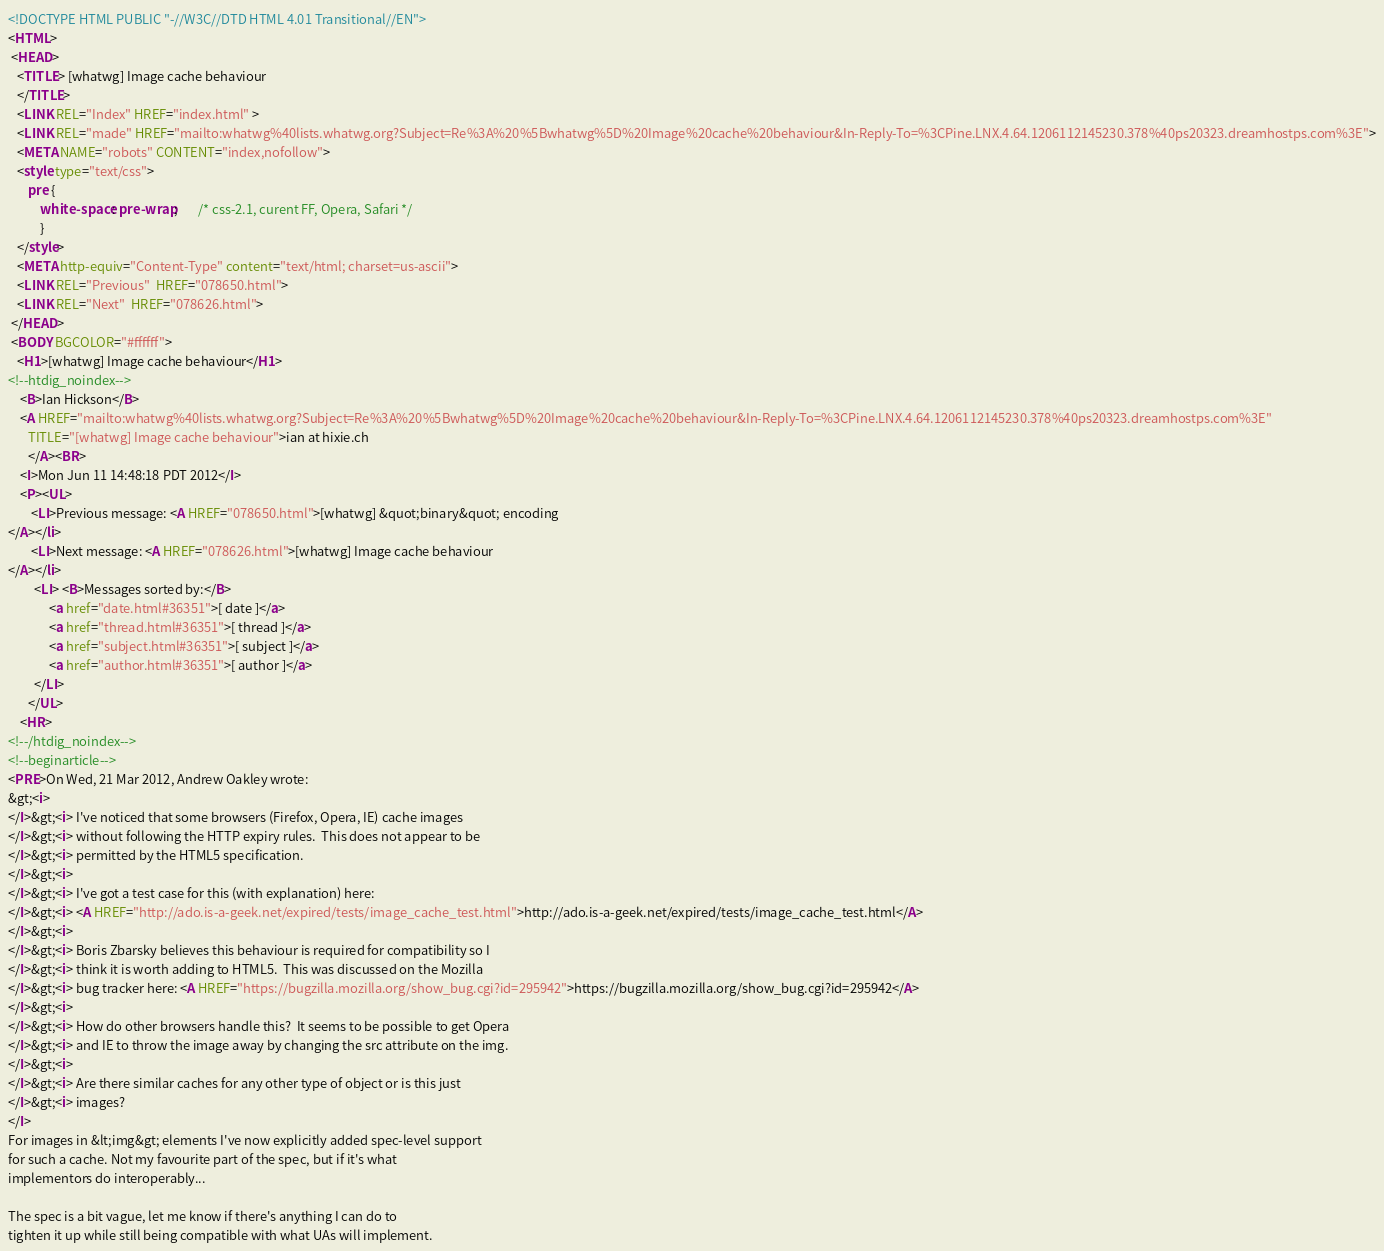Convert code to text. <code><loc_0><loc_0><loc_500><loc_500><_HTML_><!DOCTYPE HTML PUBLIC "-//W3C//DTD HTML 4.01 Transitional//EN">
<HTML>
 <HEAD>
   <TITLE> [whatwg] Image cache behaviour
   </TITLE>
   <LINK REL="Index" HREF="index.html" >
   <LINK REL="made" HREF="mailto:whatwg%40lists.whatwg.org?Subject=Re%3A%20%5Bwhatwg%5D%20Image%20cache%20behaviour&In-Reply-To=%3CPine.LNX.4.64.1206112145230.378%40ps20323.dreamhostps.com%3E">
   <META NAME="robots" CONTENT="index,nofollow">
   <style type="text/css">
       pre {
           white-space: pre-wrap;       /* css-2.1, curent FF, Opera, Safari */
           }
   </style>
   <META http-equiv="Content-Type" content="text/html; charset=us-ascii">
   <LINK REL="Previous"  HREF="078650.html">
   <LINK REL="Next"  HREF="078626.html">
 </HEAD>
 <BODY BGCOLOR="#ffffff">
   <H1>[whatwg] Image cache behaviour</H1>
<!--htdig_noindex-->
    <B>Ian Hickson</B> 
    <A HREF="mailto:whatwg%40lists.whatwg.org?Subject=Re%3A%20%5Bwhatwg%5D%20Image%20cache%20behaviour&In-Reply-To=%3CPine.LNX.4.64.1206112145230.378%40ps20323.dreamhostps.com%3E"
       TITLE="[whatwg] Image cache behaviour">ian at hixie.ch
       </A><BR>
    <I>Mon Jun 11 14:48:18 PDT 2012</I>
    <P><UL>
        <LI>Previous message: <A HREF="078650.html">[whatwg] &quot;binary&quot; encoding
</A></li>
        <LI>Next message: <A HREF="078626.html">[whatwg] Image cache behaviour
</A></li>
         <LI> <B>Messages sorted by:</B> 
              <a href="date.html#36351">[ date ]</a>
              <a href="thread.html#36351">[ thread ]</a>
              <a href="subject.html#36351">[ subject ]</a>
              <a href="author.html#36351">[ author ]</a>
         </LI>
       </UL>
    <HR>  
<!--/htdig_noindex-->
<!--beginarticle-->
<PRE>On Wed, 21 Mar 2012, Andrew Oakley wrote:
&gt;<i>
</I>&gt;<i> I've noticed that some browsers (Firefox, Opera, IE) cache images 
</I>&gt;<i> without following the HTTP expiry rules.  This does not appear to be 
</I>&gt;<i> permitted by the HTML5 specification.
</I>&gt;<i> 
</I>&gt;<i> I've got a test case for this (with explanation) here: 
</I>&gt;<i> <A HREF="http://ado.is-a-geek.net/expired/tests/image_cache_test.html">http://ado.is-a-geek.net/expired/tests/image_cache_test.html</A>
</I>&gt;<i> 
</I>&gt;<i> Boris Zbarsky believes this behaviour is required for compatibility so I 
</I>&gt;<i> think it is worth adding to HTML5.  This was discussed on the Mozilla 
</I>&gt;<i> bug tracker here: <A HREF="https://bugzilla.mozilla.org/show_bug.cgi?id=295942">https://bugzilla.mozilla.org/show_bug.cgi?id=295942</A>
</I>&gt;<i> 
</I>&gt;<i> How do other browsers handle this?  It seems to be possible to get Opera 
</I>&gt;<i> and IE to throw the image away by changing the src attribute on the img.
</I>&gt;<i> 
</I>&gt;<i> Are there similar caches for any other type of object or is this just 
</I>&gt;<i> images?
</I>
For images in &lt;img&gt; elements I've now explicitly added spec-level support 
for such a cache. Not my favourite part of the spec, but if it's what 
implementors do interoperably...

The spec is a bit vague, let me know if there's anything I can do to 
tighten it up while still being compatible with what UAs will implement.
</code> 